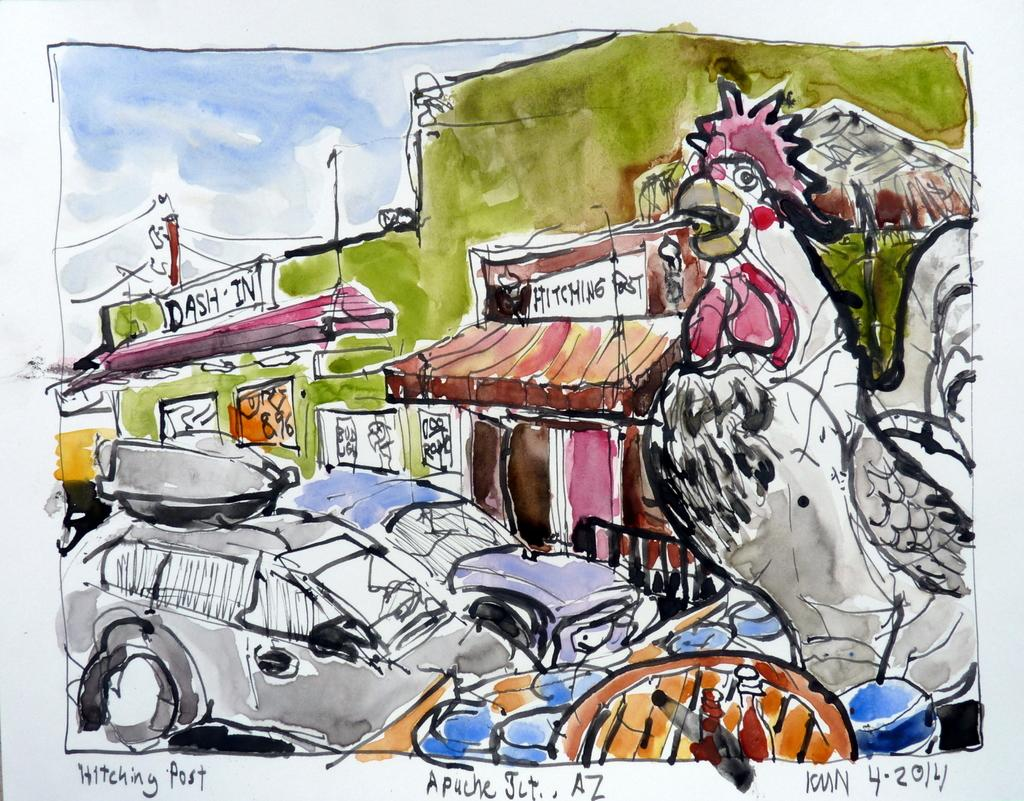What types of subjects are depicted in the paintings on the poster? The poster contains paintings of vehicles, buildings, a bird, and the sky. What is the color of the background on the poster? The background of the poster is white in color. Are there any texts on the poster? Yes, there are texts on the poster. What type of lunch is being served in the painting of the bird on the poster? There is no lunch depicted in the painting of the bird on the poster, as it only features a bird and the sky. Is there any snow visible in the painting of the sky on the poster? There is no snow visible in the painting of the sky on the poster, as it only features clouds and a blue sky. 